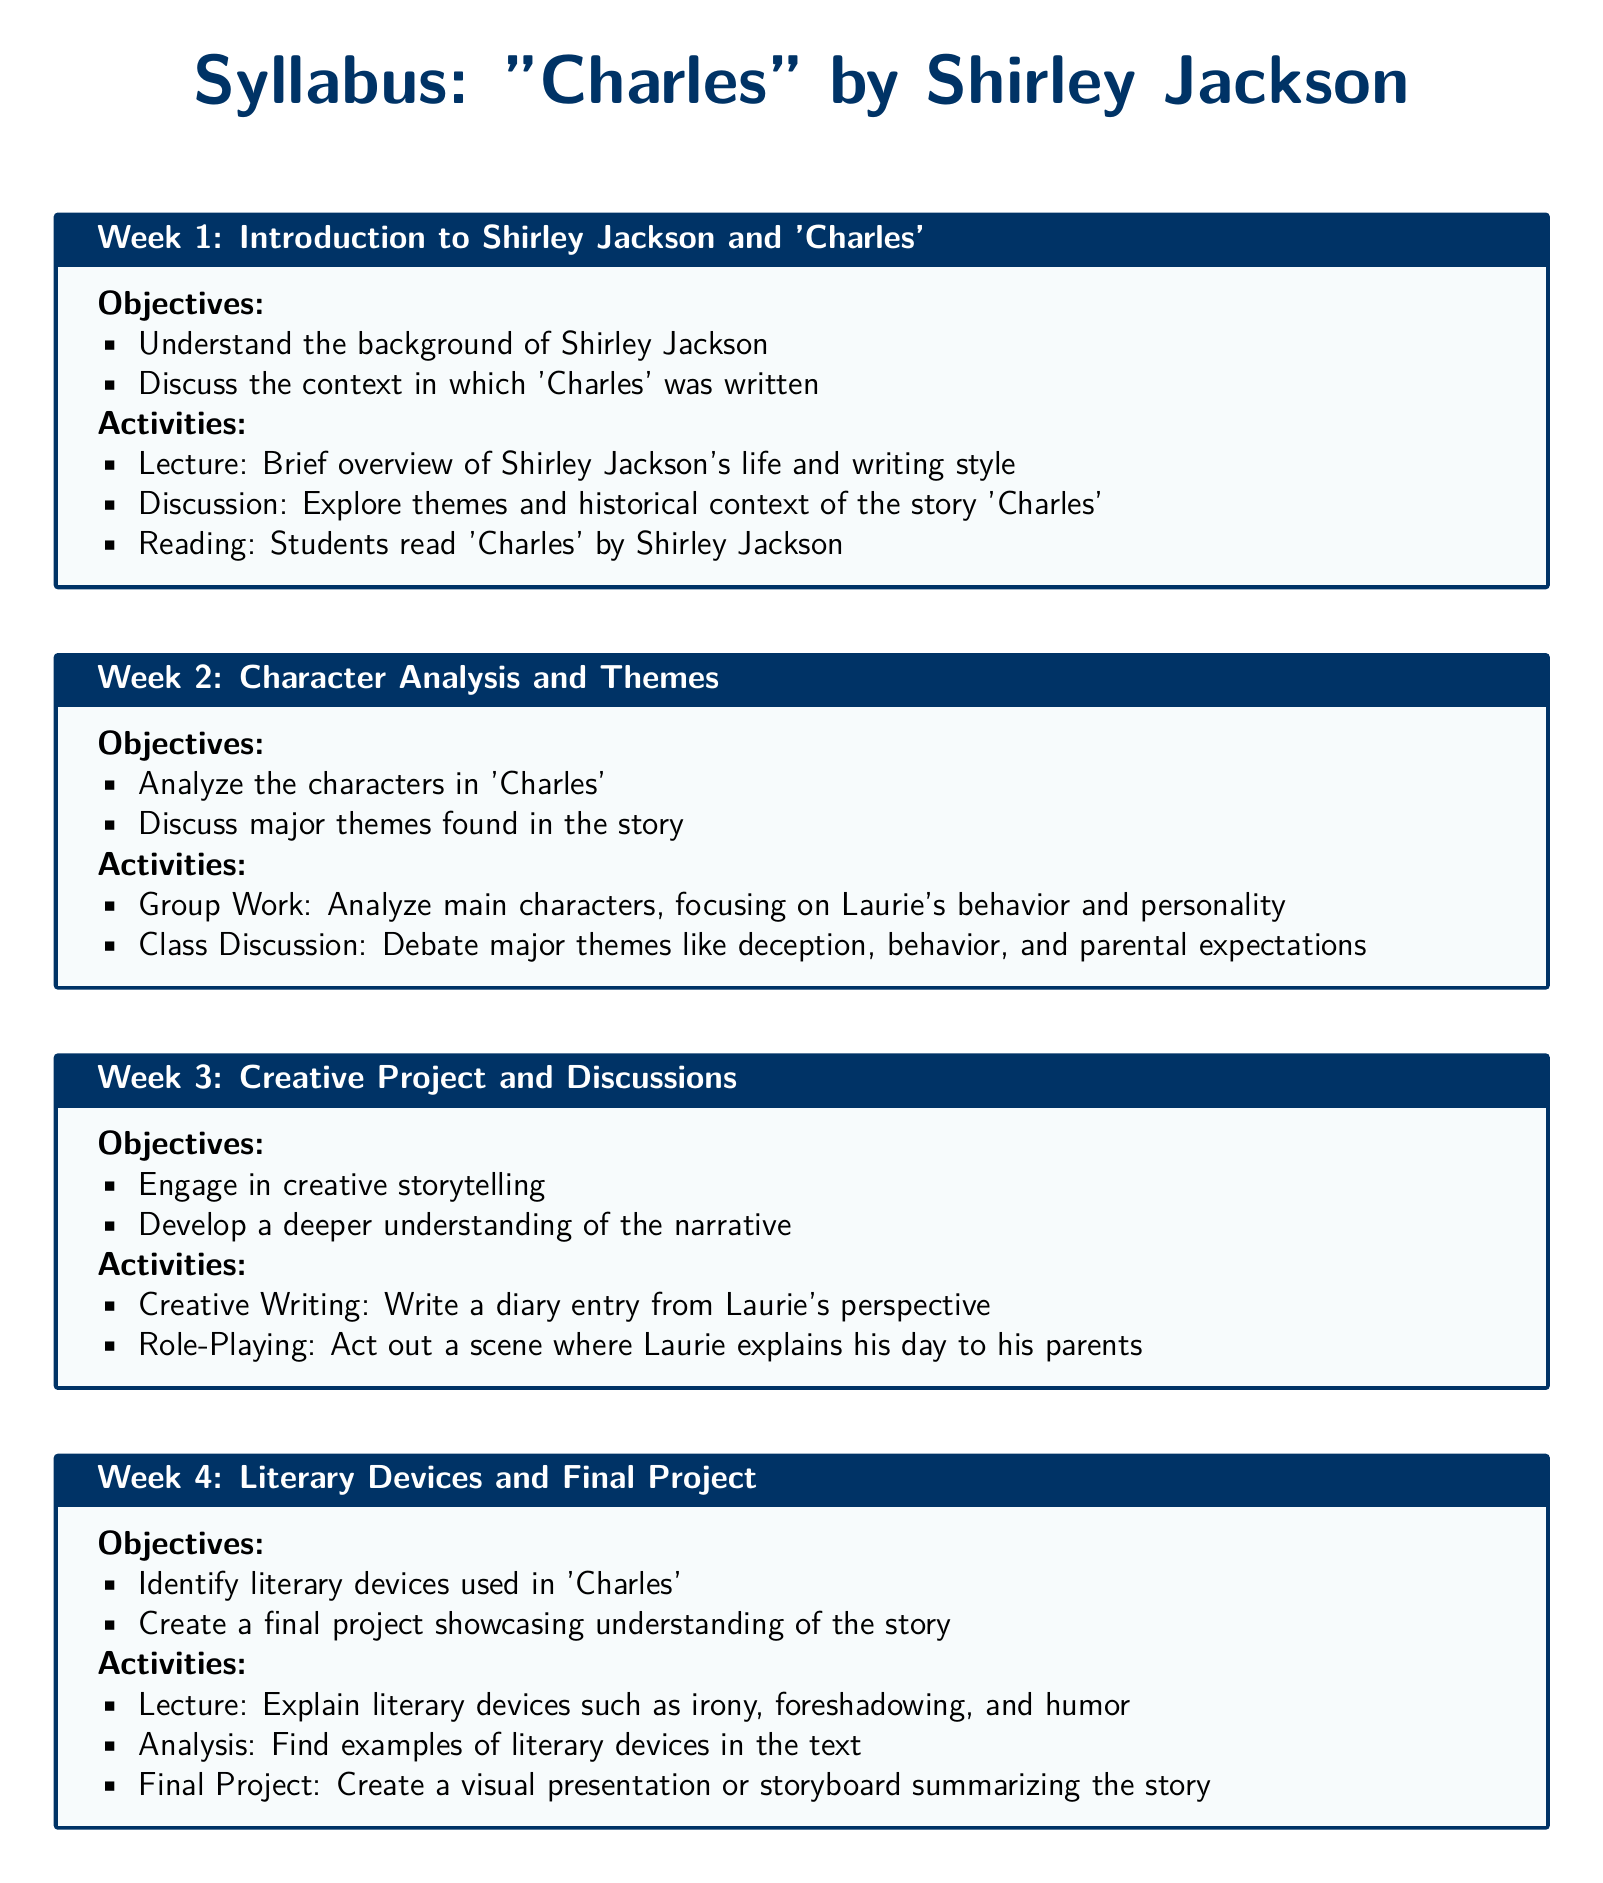What is the title of the syllabus? The title of the syllabus is explicitly stated at the top of the document.
Answer: "Charles" by Shirley Jackson Who is the author of 'Charles'? The author of the story 'Charles' is mentioned in the syllabus.
Answer: Shirley Jackson How many weeks are dedicated to the syllabus? The syllabus outlines a structured approach over several weeks.
Answer: 4 What is the main focus of Week 2? The main focus of Week 2 is stated in the objectives section.
Answer: Character Analysis and Themes What is one activity listed for Week 3? Week 3 includes interactive activities to engage students.
Answer: Role-Playing What literary devices are addressed in Week 4? The syllabus lists specific literary devices to be identified during Week 4.
Answer: irony, foreshadowing, and humor What type of project is assigned in the final week? The final project type is mentioned in the activities for Week 4.
Answer: visual presentation or storyboard What theme is debated during Week 2? A specific theme for discussion is indicated in the activities.
Answer: deception What perspective is the diary entry written from in Week 3? The perspective for the diary entry is specified in the activities section.
Answer: Laurie's perspective 